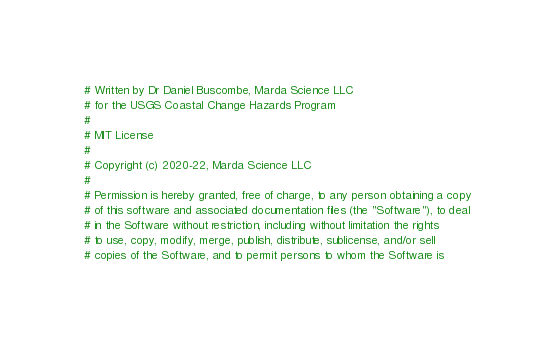Convert code to text. <code><loc_0><loc_0><loc_500><loc_500><_Python_># Written by Dr Daniel Buscombe, Marda Science LLC
# for the USGS Coastal Change Hazards Program
#
# MIT License
#
# Copyright (c) 2020-22, Marda Science LLC
#
# Permission is hereby granted, free of charge, to any person obtaining a copy
# of this software and associated documentation files (the "Software"), to deal
# in the Software without restriction, including without limitation the rights
# to use, copy, modify, merge, publish, distribute, sublicense, and/or sell
# copies of the Software, and to permit persons to whom the Software is</code> 